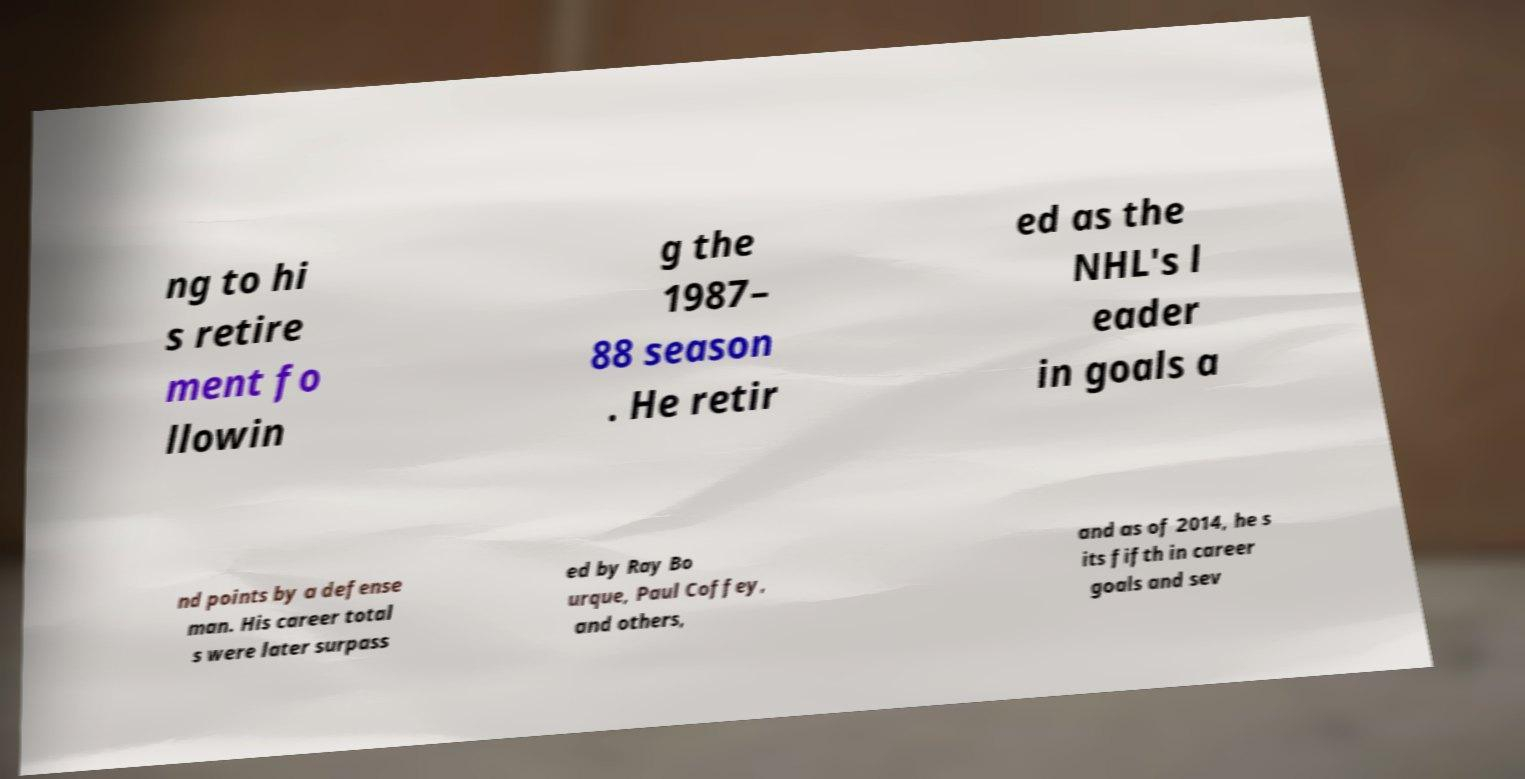For documentation purposes, I need the text within this image transcribed. Could you provide that? ng to hi s retire ment fo llowin g the 1987– 88 season . He retir ed as the NHL's l eader in goals a nd points by a defense man. His career total s were later surpass ed by Ray Bo urque, Paul Coffey, and others, and as of 2014, he s its fifth in career goals and sev 